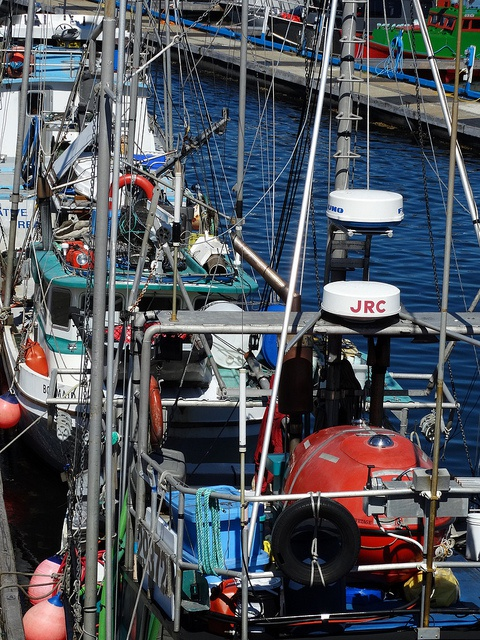Describe the objects in this image and their specific colors. I can see boat in gray, black, darkgray, and lightgray tones, boat in gray, black, darkgray, and lightgray tones, and boat in gray, darkgray, and black tones in this image. 